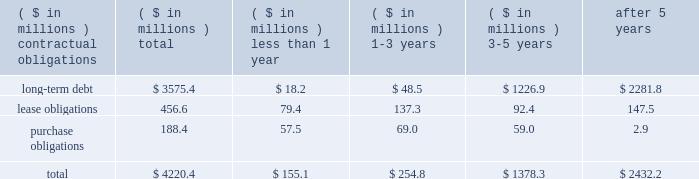The company consolidates the assets and liabilities of several entities from which it leases office buildings and corporate aircraft .
These entities have been determined to be variable interest entities and the company has been determined to be the primary beneficiary of these entities .
Due to the consolidation of these entities , the company reflects in its balance sheet : property , plant and equipment of $ 156 million and $ 183 million , other assets of $ 14 million and $ 12 million , long-term debt of $ 150 million ( including current maturities of $ 6 million ) and $ 192 million ( including current maturities of $ 8 million ) , minority interest liabilities of $ 22 million and $ 6 million , and other accrued liabilities of $ 1 million and $ 0 , as of may 27 , 2007 and may 28 , 2006 , respectively .
The liabilities recognized as a result of consolidating these entities do not represent additional claims on the general assets of the company .
The creditors of these entities have claims only on the assets of the specific variable interest entities .
Obligations and commitments as part of its ongoing operations , the company enters into arrangements that obligate the company to make future payments under contracts such as debt agreements , lease agreements , and unconditional purchase obligations ( i.e. , obligations to transfer funds in the future for fixed or minimum quantities of goods or services at fixed or minimum prices , such as 201ctake-or-pay 201d contracts ) .
The unconditional purchase obligation arrangements are entered into by the company in its normal course of business in order to ensure adequate levels of sourced product are available to the company .
Capital lease and debt obligations , which totaled $ 3.6 billion at may 27 , 2007 , are currently recognized as liabilities in the company 2019s consolidated balance sheet .
Operating lease obligations and unconditional purchase obligations , which totaled $ 645 million at may 27 , 2007 , are not recognized as liabilities in the company 2019s consolidated balance sheet , in accordance with generally accepted accounting principles .
A summary of the company 2019s contractual obligations at the end of fiscal 2007 is as follows ( including obligations of discontinued operations ) : .
The company 2019s total obligations of approximately $ 4.2 billion reflect a decrease of approximately $ 237 million from the company 2019s 2006 fiscal year-end .
The decrease was due primarily to a reduction of lease obligations in connection with the sale of the packaged meats operations .
The company is also contractually obligated to pay interest on its long-term debt obligations .
The weighted average interest rate of the long-term debt obligations outstanding as of may 27 , 2007 was approximately 7.2%. .
What percentage of the total contractual obligations at the end of fiscal 2007 are comprised of long-term debt? 
Computations: (3575.4 / 4220.4)
Answer: 0.84717. 